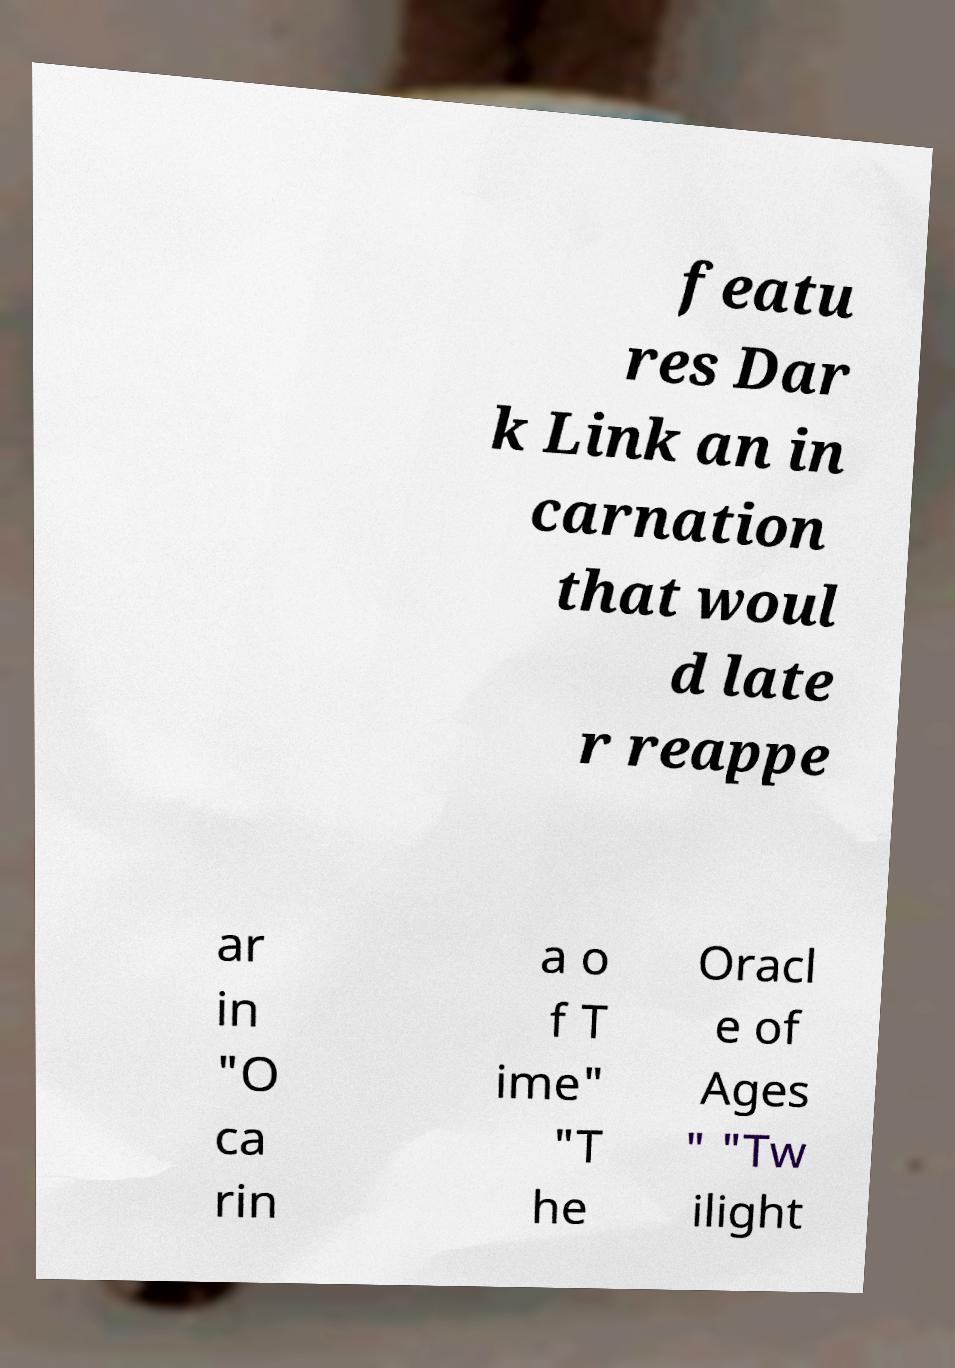Could you assist in decoding the text presented in this image and type it out clearly? featu res Dar k Link an in carnation that woul d late r reappe ar in "O ca rin a o f T ime" "T he Oracl e of Ages " "Tw ilight 